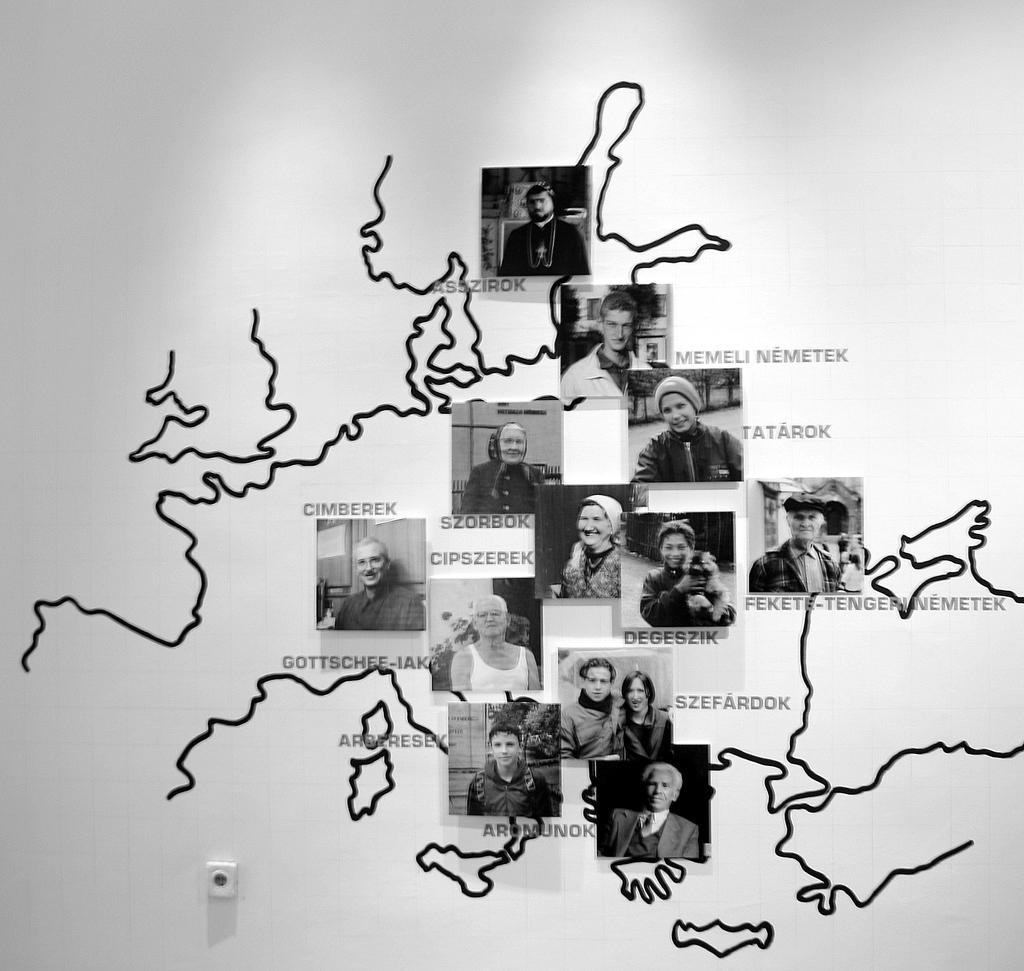Please provide a concise description of this image. In this image there is a board. On the board there are photos, text and curved lines. 